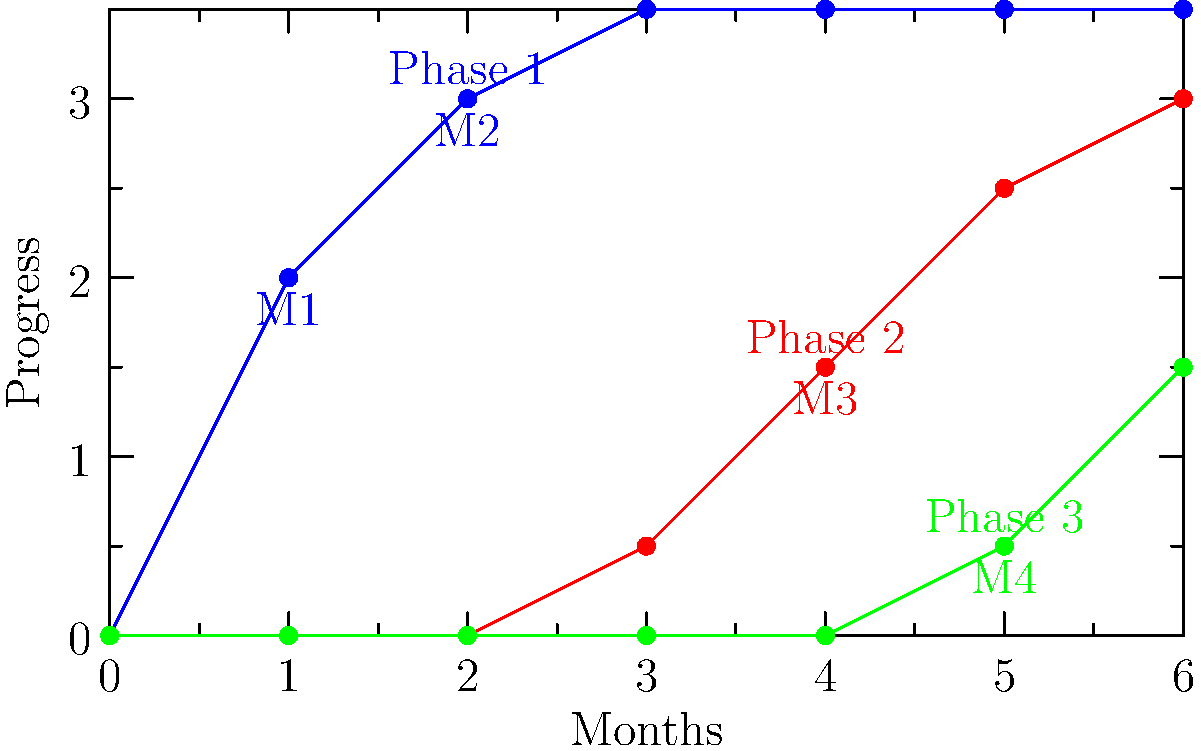Analyze the recovery timeline chart showing three phases of a disaster recovery project. Which phase has the steepest initial slope, indicating the fastest rate of progress at the beginning, and at what month does this phase reach its maximum progress? To answer this question, we need to analyze the slopes and progress of each phase:

1. Phase 1 (Blue):
   - Starts immediately and progresses rapidly from month 0 to 2.
   - The slope is steepest in the first month.
   - Reaches maximum progress at month 3.

2. Phase 2 (Red):
   - Starts at month 3 and progresses steadily until month 6.
   - The slope is consistent but less steep than Phase 1's initial slope.

3. Phase 3 (Green):
   - Starts at month 5 and progresses slowly.
   - The slope is the least steep of all phases.

Comparing the initial slopes:
- Phase 1 has the steepest initial slope, rising from 0 to 2 units in the first month.
- Phase 2 and 3 have gentler initial slopes.

Therefore, Phase 1 has the fastest rate of progress at the beginning.

To determine when Phase 1 reaches its maximum progress:
- The line for Phase 1 plateaus (becomes horizontal) at month 3.
- This indicates that Phase 1 reaches its maximum progress at month 3.
Answer: Phase 1, month 3 